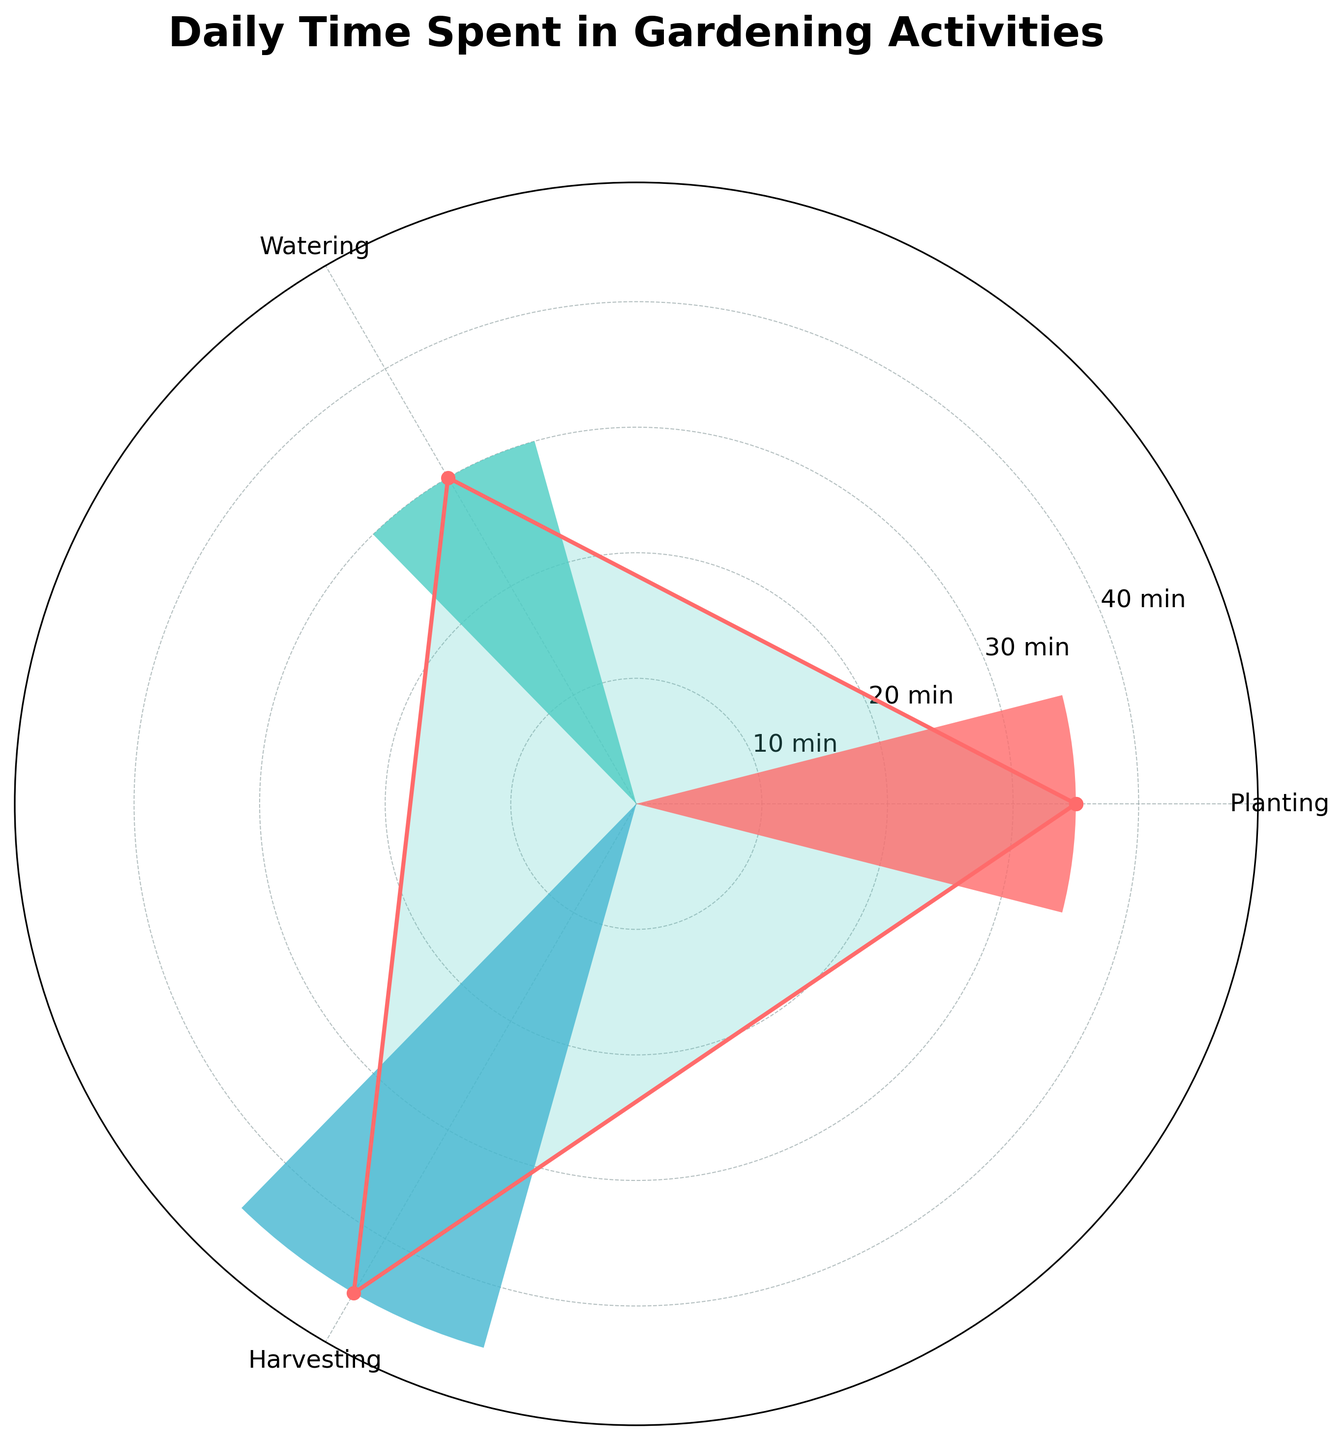What are the activities shown in the chart? The chart visually represents different gardening activities. These activities are identified by labels at specific angles in the plot.
Answer: Planting, Watering, Harvesting Which activity requires the most time? By examining the distances from the center of the chart to the outer points, the longest distance indicates the activity that consumes the most time.
Answer: Watering How many minutes are spent on planting activities? This requires adding the time spent on each planting activity, which can be inferred by observing and summing the time values of the relevant segments.
Answer: 35 minutes How does the time spent on Watering compare to the time spent on Harvesting? Observe the lengths of the segments for both activities. Watering has a longer segment compared to Harvesting, indicating more time spent.
Answer: More time is spent on Watering than Harvesting By how many minutes does Watering exceed the shortest activity? Identify the segment with the shortest length (Planting) and compare its time with that of Watering. The difference between the two times represents the excess.
Answer: 25 minutes What is the average time spent on activities daily? Sum all the time spent on each activity and divide by the number of activities to find the average. (35 + 30 + 45) / 3 = 110 / 3 = 36.67
Answer: 36.67 minutes Which two activities combined take the same amount of time as Watering? Add the times of different combinations of two activities and compare with the time spent on Watering (30 min).
Answer: Planting and Harvesting Is there an activity that takes exactly half the time as Watering? Check the time values of other activities and compare them to see if any equals half of Watering's time. Harvesting takes 25 minutes, which is not exactly half of 30 minutes for Watering.
Answer: No What is the range of time spent on different activities? The range is calculated by subtracting the smallest time value from the largest time value. 45 (Harvesting) - 15 (Planting Oregano) = 30
Answer: 30 minutes 